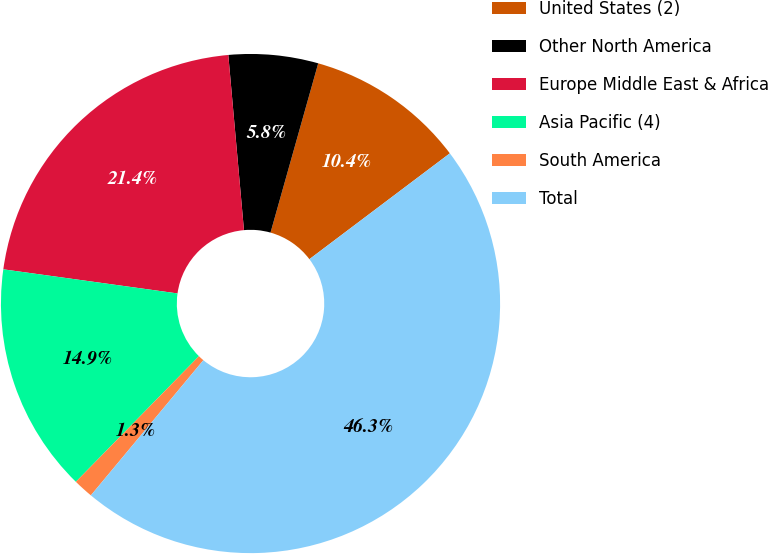Convert chart to OTSL. <chart><loc_0><loc_0><loc_500><loc_500><pie_chart><fcel>United States (2)<fcel>Other North America<fcel>Europe Middle East & Africa<fcel>Asia Pacific (4)<fcel>South America<fcel>Total<nl><fcel>10.35%<fcel>5.79%<fcel>21.39%<fcel>14.85%<fcel>1.29%<fcel>46.32%<nl></chart> 